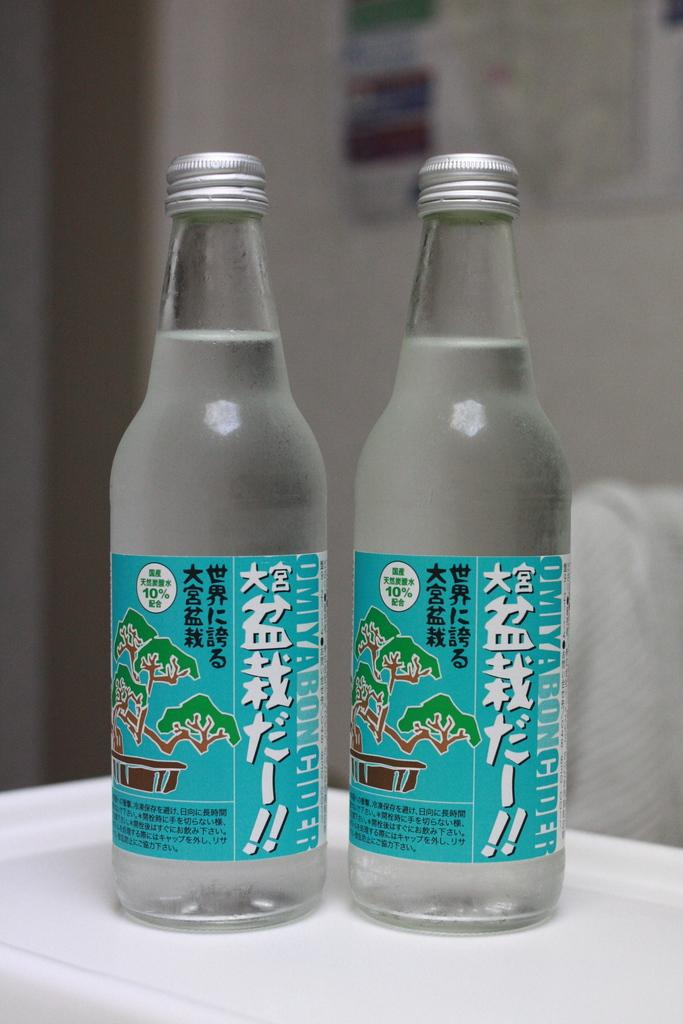<image>
Provide a brief description of the given image. two clear bottles of liquid with 10% written on the label 